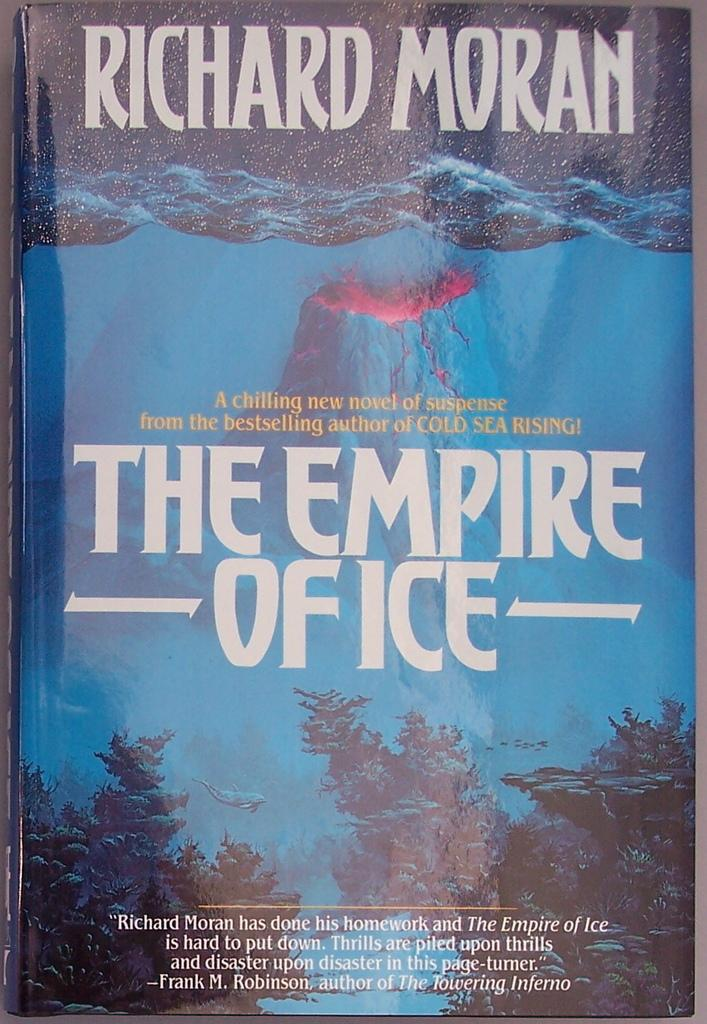<image>
Relay a brief, clear account of the picture shown. A book called The Empire of Ice has a volcano on the cover. 